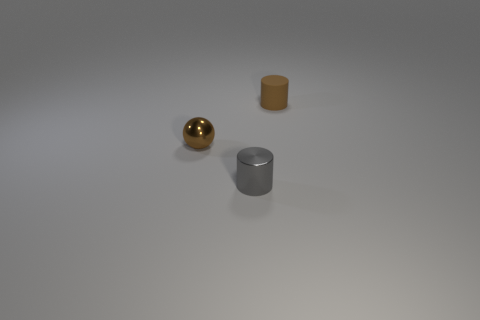Are there any other things that are the same material as the tiny brown cylinder?
Give a very brief answer. No. How many small brown matte objects are the same shape as the small gray thing?
Offer a very short reply. 1. There is a ball that is the same size as the gray cylinder; what is its material?
Give a very brief answer. Metal. Are there any small gray cylinders made of the same material as the tiny brown sphere?
Offer a very short reply. Yes. The small thing that is both behind the small gray cylinder and in front of the tiny brown matte cylinder is what color?
Your response must be concise. Brown. What number of other things are the same color as the rubber thing?
Ensure brevity in your answer.  1. The tiny brown thing on the left side of the thing that is in front of the tiny brown ball behind the small gray shiny thing is made of what material?
Provide a short and direct response. Metal. What number of blocks are purple rubber objects or brown matte objects?
Provide a short and direct response. 0. What number of objects are on the left side of the shiny thing in front of the tiny brown shiny ball that is to the left of the gray metallic cylinder?
Offer a very short reply. 1. Does the small brown rubber thing have the same shape as the tiny gray thing?
Offer a terse response. Yes. 